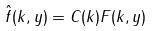<formula> <loc_0><loc_0><loc_500><loc_500>\hat { f } ( k , y ) = C ( k ) F ( k , y )</formula> 